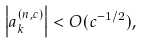<formula> <loc_0><loc_0><loc_500><loc_500>\left | a _ { k } ^ { ( n , c ) } \right | < O ( c ^ { - 1 / 2 } ) ,</formula> 